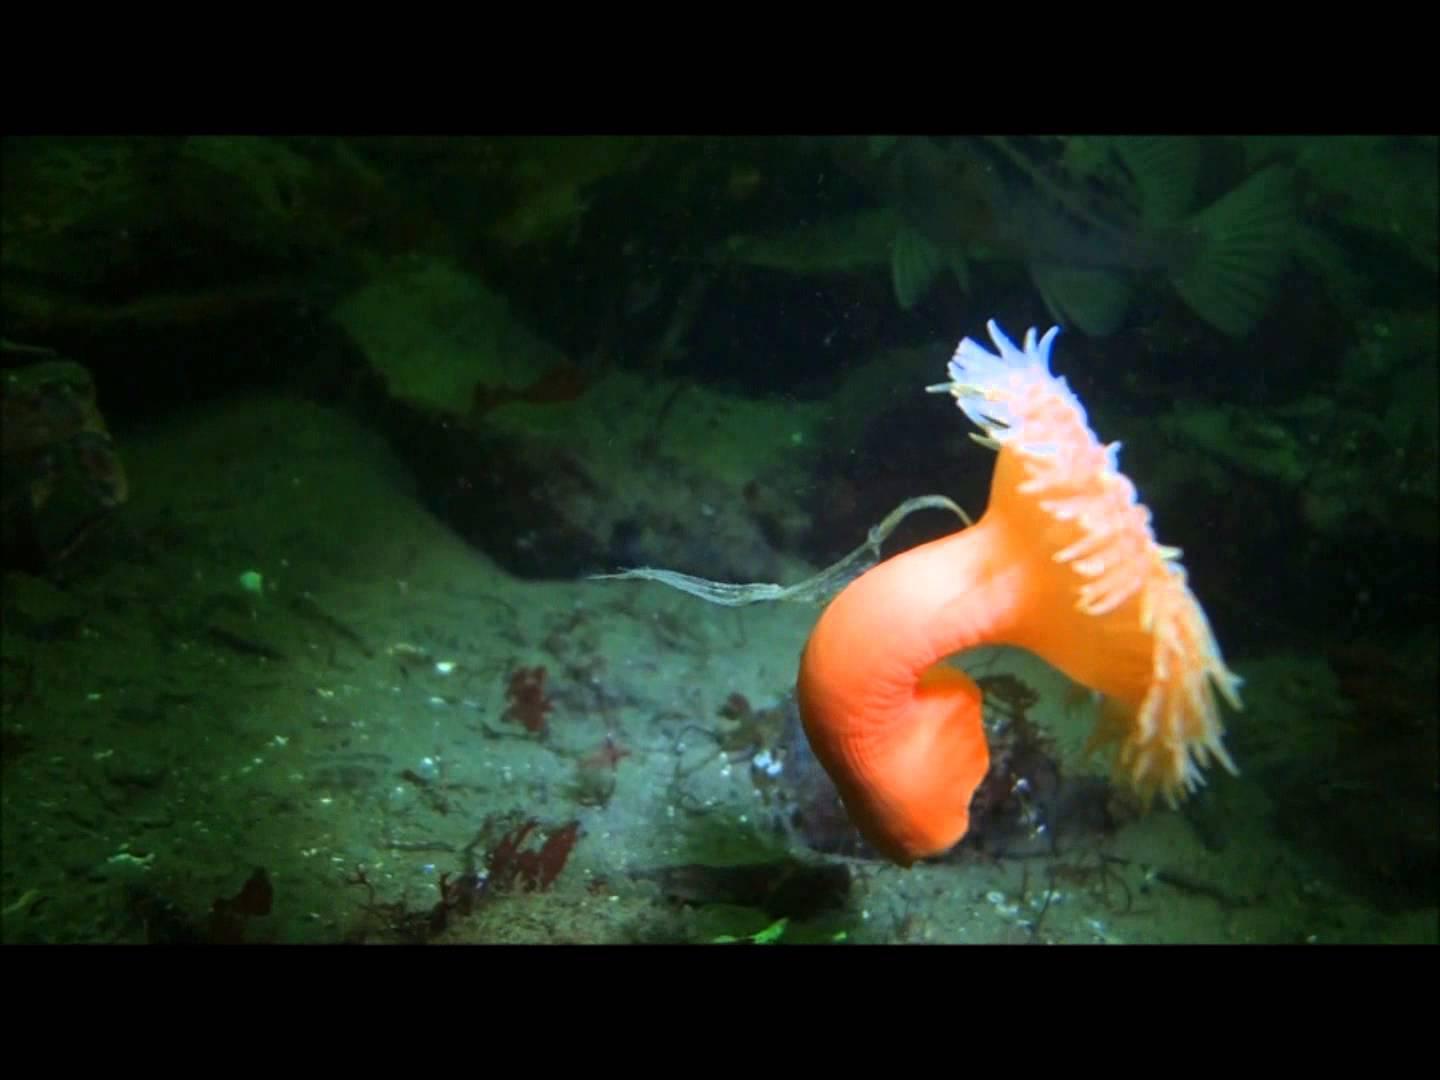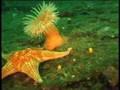The first image is the image on the left, the second image is the image on the right. Assess this claim about the two images: "Several fish are swimming in one of the images.". Correct or not? Answer yes or no. No. The first image is the image on the left, the second image is the image on the right. Considering the images on both sides, is "An image contains at least three clown fish." valid? Answer yes or no. No. 